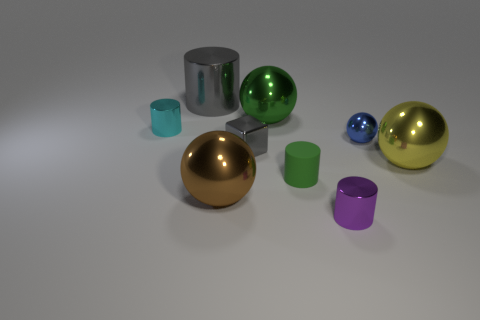There is a metal thing that is both behind the cyan object and on the right side of the big cylinder; how big is it? The metal object behind the cyan cup and to the right of the silver cylinder appears to be relatively small, with a diameter that seems to be slightly less than that of the cyan cup, which is itself smaller than the cylinder. Its size is comparable to that of the smaller spheres in the image, suggesting it might be around the same size as a standard tennis ball. 